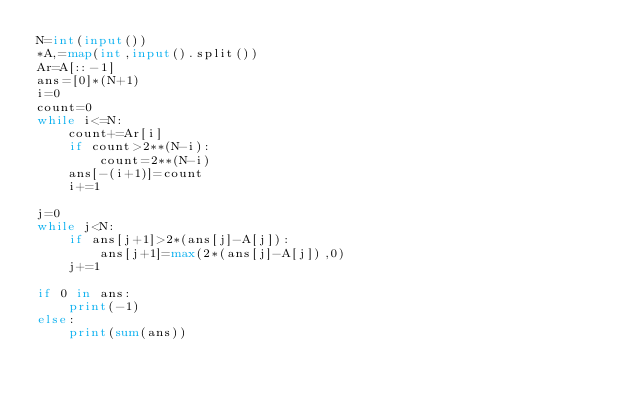Convert code to text. <code><loc_0><loc_0><loc_500><loc_500><_Python_>N=int(input())
*A,=map(int,input().split())
Ar=A[::-1]
ans=[0]*(N+1)
i=0
count=0
while i<=N:
    count+=Ar[i]
    if count>2**(N-i):
        count=2**(N-i)
    ans[-(i+1)]=count
    i+=1

j=0
while j<N:
    if ans[j+1]>2*(ans[j]-A[j]):
        ans[j+1]=max(2*(ans[j]-A[j]),0)
    j+=1

if 0 in ans:
    print(-1)
else:
    print(sum(ans))</code> 